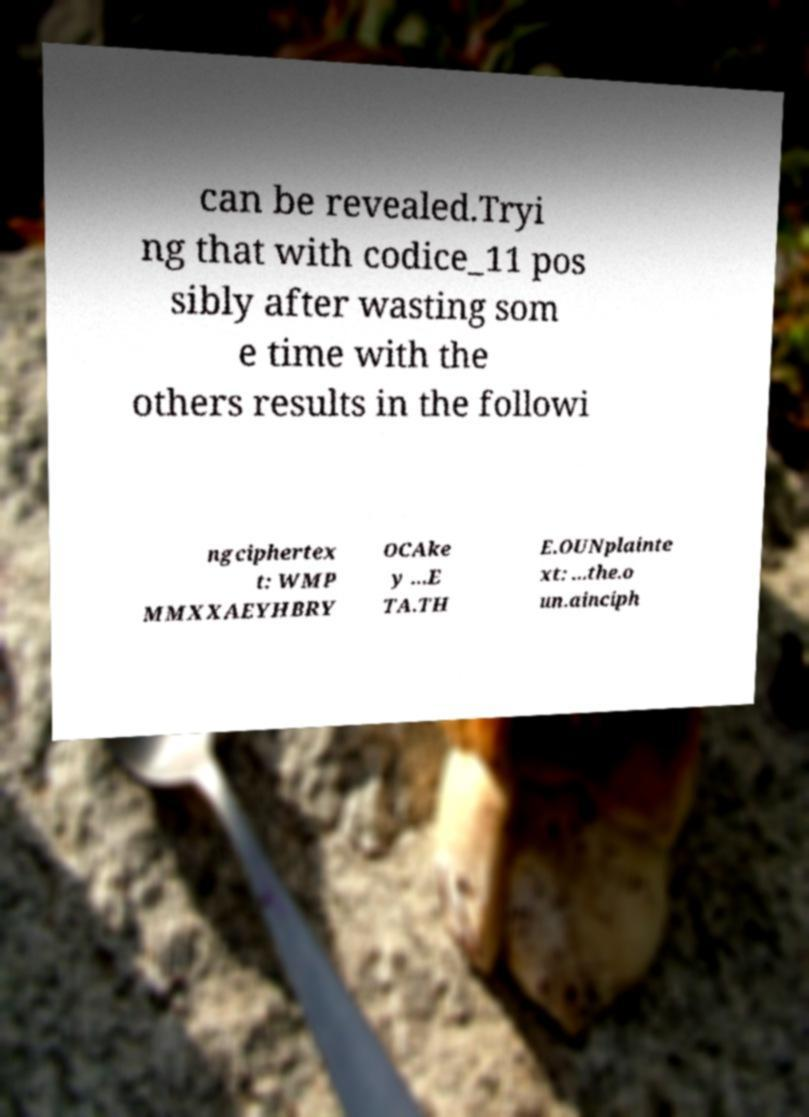What messages or text are displayed in this image? I need them in a readable, typed format. can be revealed.Tryi ng that with codice_11 pos sibly after wasting som e time with the others results in the followi ngciphertex t: WMP MMXXAEYHBRY OCAke y ...E TA.TH E.OUNplainte xt: ...the.o un.ainciph 